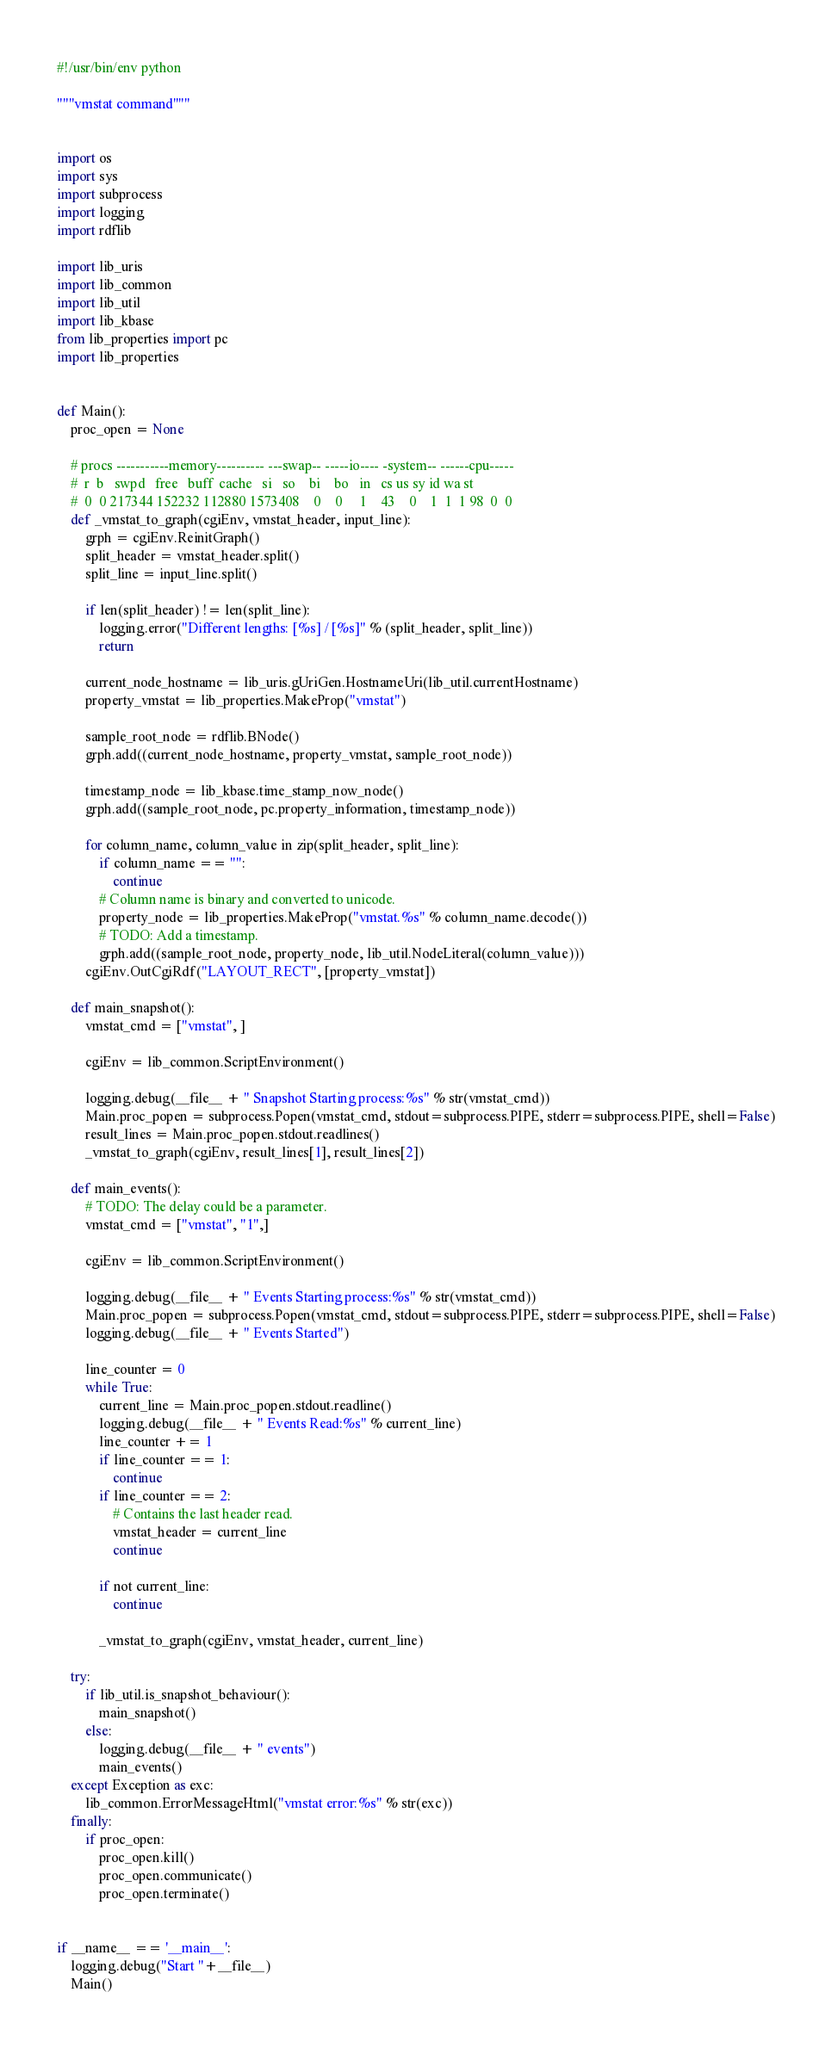Convert code to text. <code><loc_0><loc_0><loc_500><loc_500><_Python_>#!/usr/bin/env python

"""vmstat command"""


import os
import sys
import subprocess
import logging
import rdflib

import lib_uris
import lib_common
import lib_util
import lib_kbase
from lib_properties import pc
import lib_properties


def Main():
    proc_open = None

    # procs -----------memory---------- ---swap-- -----io---- -system-- ------cpu-----
    #  r  b   swpd   free   buff  cache   si   so    bi    bo   in   cs us sy id wa st
    #  0  0 217344 152232 112880 1573408    0    0     1    43    0    1  1  1 98  0  0
    def _vmstat_to_graph(cgiEnv, vmstat_header, input_line):
        grph = cgiEnv.ReinitGraph()
        split_header = vmstat_header.split()
        split_line = input_line.split()

        if len(split_header) != len(split_line):
            logging.error("Different lengths: [%s] / [%s]" % (split_header, split_line))
            return

        current_node_hostname = lib_uris.gUriGen.HostnameUri(lib_util.currentHostname)
        property_vmstat = lib_properties.MakeProp("vmstat")

        sample_root_node = rdflib.BNode()
        grph.add((current_node_hostname, property_vmstat, sample_root_node))

        timestamp_node = lib_kbase.time_stamp_now_node()
        grph.add((sample_root_node, pc.property_information, timestamp_node))

        for column_name, column_value in zip(split_header, split_line):
            if column_name == "":
                continue
            # Column name is binary and converted to unicode.
            property_node = lib_properties.MakeProp("vmstat.%s" % column_name.decode())
            # TODO: Add a timestamp.
            grph.add((sample_root_node, property_node, lib_util.NodeLiteral(column_value)))
        cgiEnv.OutCgiRdf("LAYOUT_RECT", [property_vmstat])

    def main_snapshot():
        vmstat_cmd = ["vmstat", ]

        cgiEnv = lib_common.ScriptEnvironment()

        logging.debug(__file__ + " Snapshot Starting process:%s" % str(vmstat_cmd))
        Main.proc_popen = subprocess.Popen(vmstat_cmd, stdout=subprocess.PIPE, stderr=subprocess.PIPE, shell=False)
        result_lines = Main.proc_popen.stdout.readlines()
        _vmstat_to_graph(cgiEnv, result_lines[1], result_lines[2])

    def main_events():
        # TODO: The delay could be a parameter.
        vmstat_cmd = ["vmstat", "1",]

        cgiEnv = lib_common.ScriptEnvironment()

        logging.debug(__file__ + " Events Starting process:%s" % str(vmstat_cmd))
        Main.proc_popen = subprocess.Popen(vmstat_cmd, stdout=subprocess.PIPE, stderr=subprocess.PIPE, shell=False)
        logging.debug(__file__ + " Events Started")

        line_counter = 0
        while True:
            current_line = Main.proc_popen.stdout.readline()
            logging.debug(__file__ + " Events Read:%s" % current_line)
            line_counter += 1
            if line_counter == 1:
                continue
            if line_counter == 2:
                # Contains the last header read.
                vmstat_header = current_line
                continue

            if not current_line:
                continue

            _vmstat_to_graph(cgiEnv, vmstat_header, current_line)

    try:
        if lib_util.is_snapshot_behaviour():
            main_snapshot()
        else:
            logging.debug(__file__ + " events")
            main_events()
    except Exception as exc:
        lib_common.ErrorMessageHtml("vmstat error:%s" % str(exc))
    finally:
        if proc_open:
            proc_open.kill()
            proc_open.communicate()
            proc_open.terminate()


if __name__ == '__main__':
    logging.debug("Start "+__file__)
    Main()
</code> 